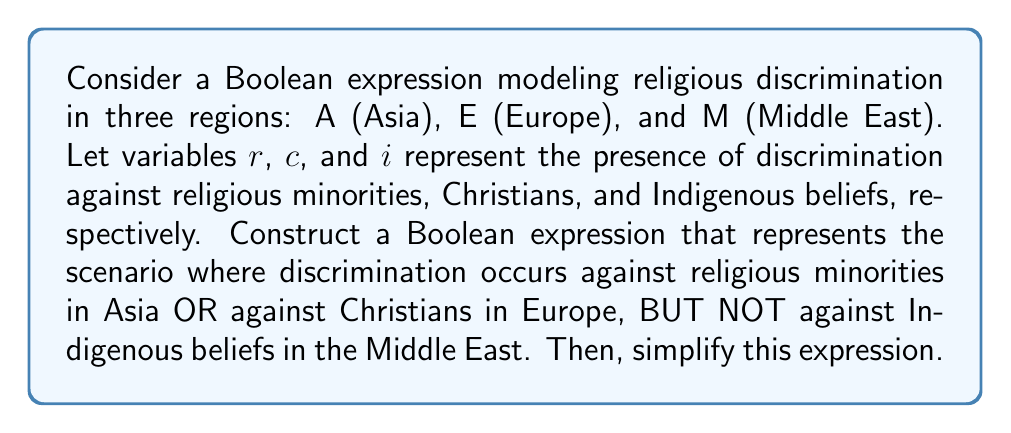Could you help me with this problem? Let's approach this step-by-step:

1) First, we need to define our Boolean variables:
   $A_r$: Discrimination against religious minorities in Asia
   $E_c$: Discrimination against Christians in Europe
   $M_i$: Discrimination against Indigenous beliefs in the Middle East

2) The scenario described can be expressed as:
   $$(A_r \text{ OR } E_c) \text{ AND NOT } M_i$$

3) In Boolean algebra, this translates to:
   $$(A_r + E_c) \cdot \overline{M_i}$$

4) Using the distributive property, we can expand this:
   $$A_r \cdot \overline{M_i} + E_c \cdot \overline{M_i}$$

5) This expression is already in its simplest form, as it represents the two possible scenarios:
   - Discrimination against religious minorities in Asia, but not against Indigenous beliefs in the Middle East
   - Discrimination against Christians in Europe, but not against Indigenous beliefs in the Middle East

6) Therefore, our final simplified Boolean expression is:
   $$A_r \cdot \overline{M_i} + E_c \cdot \overline{M_i}$$
Answer: $A_r \cdot \overline{M_i} + E_c \cdot \overline{M_i}$ 